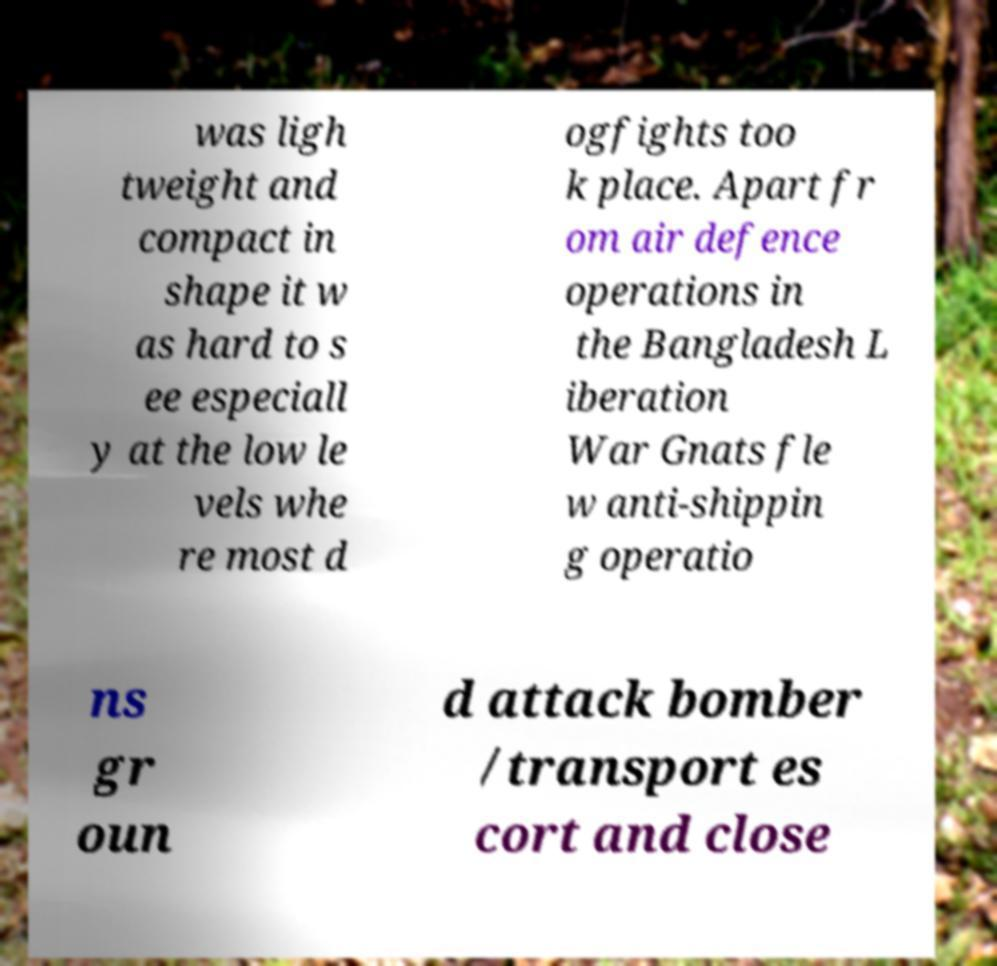I need the written content from this picture converted into text. Can you do that? was ligh tweight and compact in shape it w as hard to s ee especiall y at the low le vels whe re most d ogfights too k place. Apart fr om air defence operations in the Bangladesh L iberation War Gnats fle w anti-shippin g operatio ns gr oun d attack bomber /transport es cort and close 